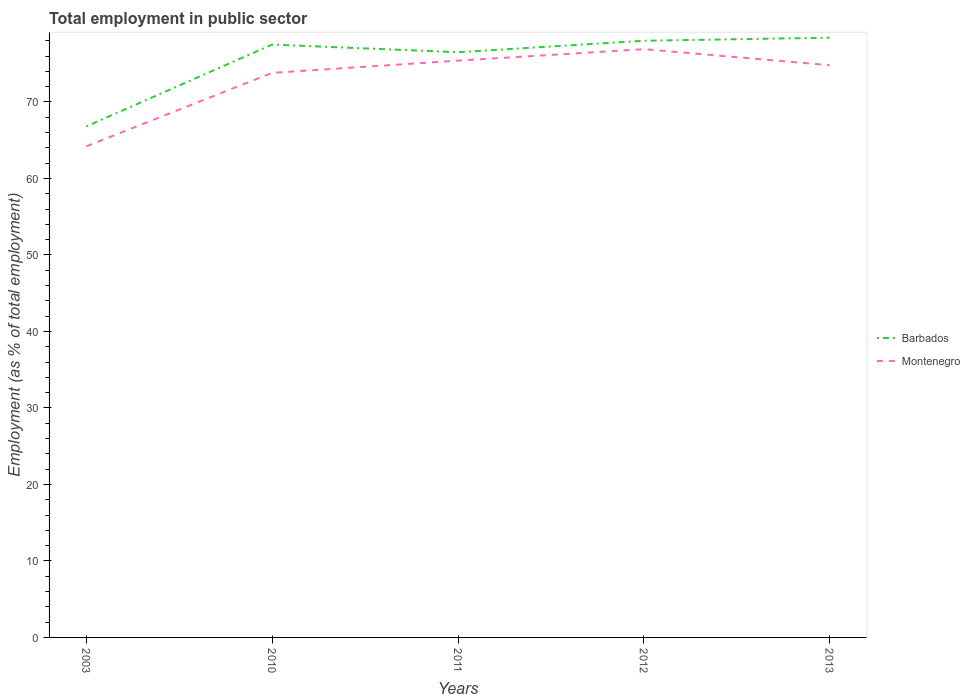How many different coloured lines are there?
Your response must be concise. 2. Does the line corresponding to Barbados intersect with the line corresponding to Montenegro?
Make the answer very short. No. Is the number of lines equal to the number of legend labels?
Ensure brevity in your answer.  Yes. Across all years, what is the maximum employment in public sector in Barbados?
Keep it short and to the point. 66.8. In which year was the employment in public sector in Montenegro maximum?
Make the answer very short. 2003. What is the total employment in public sector in Barbados in the graph?
Ensure brevity in your answer.  -9.7. What is the difference between the highest and the second highest employment in public sector in Montenegro?
Ensure brevity in your answer.  12.7. What is the difference between the highest and the lowest employment in public sector in Barbados?
Your response must be concise. 4. How many years are there in the graph?
Offer a terse response. 5. Does the graph contain grids?
Offer a very short reply. No. Where does the legend appear in the graph?
Provide a succinct answer. Center right. How many legend labels are there?
Offer a very short reply. 2. What is the title of the graph?
Provide a short and direct response. Total employment in public sector. What is the label or title of the X-axis?
Offer a very short reply. Years. What is the label or title of the Y-axis?
Offer a very short reply. Employment (as % of total employment). What is the Employment (as % of total employment) of Barbados in 2003?
Provide a succinct answer. 66.8. What is the Employment (as % of total employment) of Montenegro in 2003?
Provide a succinct answer. 64.2. What is the Employment (as % of total employment) in Barbados in 2010?
Provide a short and direct response. 77.5. What is the Employment (as % of total employment) in Montenegro in 2010?
Offer a very short reply. 73.8. What is the Employment (as % of total employment) in Barbados in 2011?
Offer a very short reply. 76.5. What is the Employment (as % of total employment) of Montenegro in 2011?
Make the answer very short. 75.4. What is the Employment (as % of total employment) of Montenegro in 2012?
Your answer should be compact. 76.9. What is the Employment (as % of total employment) in Barbados in 2013?
Your response must be concise. 78.4. What is the Employment (as % of total employment) in Montenegro in 2013?
Offer a very short reply. 74.8. Across all years, what is the maximum Employment (as % of total employment) of Barbados?
Make the answer very short. 78.4. Across all years, what is the maximum Employment (as % of total employment) of Montenegro?
Offer a very short reply. 76.9. Across all years, what is the minimum Employment (as % of total employment) in Barbados?
Provide a succinct answer. 66.8. Across all years, what is the minimum Employment (as % of total employment) of Montenegro?
Provide a short and direct response. 64.2. What is the total Employment (as % of total employment) of Barbados in the graph?
Your response must be concise. 377.2. What is the total Employment (as % of total employment) of Montenegro in the graph?
Your response must be concise. 365.1. What is the difference between the Employment (as % of total employment) of Barbados in 2003 and that in 2010?
Make the answer very short. -10.7. What is the difference between the Employment (as % of total employment) in Barbados in 2003 and that in 2011?
Provide a succinct answer. -9.7. What is the difference between the Employment (as % of total employment) of Montenegro in 2003 and that in 2011?
Make the answer very short. -11.2. What is the difference between the Employment (as % of total employment) of Barbados in 2010 and that in 2012?
Provide a short and direct response. -0.5. What is the difference between the Employment (as % of total employment) of Montenegro in 2011 and that in 2012?
Keep it short and to the point. -1.5. What is the difference between the Employment (as % of total employment) of Barbados in 2012 and that in 2013?
Give a very brief answer. -0.4. What is the difference between the Employment (as % of total employment) in Barbados in 2003 and the Employment (as % of total employment) in Montenegro in 2010?
Your response must be concise. -7. What is the difference between the Employment (as % of total employment) of Barbados in 2003 and the Employment (as % of total employment) of Montenegro in 2011?
Keep it short and to the point. -8.6. What is the difference between the Employment (as % of total employment) of Barbados in 2003 and the Employment (as % of total employment) of Montenegro in 2012?
Offer a terse response. -10.1. What is the difference between the Employment (as % of total employment) of Barbados in 2003 and the Employment (as % of total employment) of Montenegro in 2013?
Offer a very short reply. -8. What is the difference between the Employment (as % of total employment) in Barbados in 2010 and the Employment (as % of total employment) in Montenegro in 2012?
Your answer should be compact. 0.6. What is the difference between the Employment (as % of total employment) of Barbados in 2010 and the Employment (as % of total employment) of Montenegro in 2013?
Make the answer very short. 2.7. What is the difference between the Employment (as % of total employment) in Barbados in 2011 and the Employment (as % of total employment) in Montenegro in 2012?
Provide a succinct answer. -0.4. What is the average Employment (as % of total employment) of Barbados per year?
Provide a short and direct response. 75.44. What is the average Employment (as % of total employment) of Montenegro per year?
Keep it short and to the point. 73.02. In the year 2003, what is the difference between the Employment (as % of total employment) of Barbados and Employment (as % of total employment) of Montenegro?
Ensure brevity in your answer.  2.6. In the year 2010, what is the difference between the Employment (as % of total employment) in Barbados and Employment (as % of total employment) in Montenegro?
Offer a terse response. 3.7. In the year 2011, what is the difference between the Employment (as % of total employment) of Barbados and Employment (as % of total employment) of Montenegro?
Make the answer very short. 1.1. In the year 2013, what is the difference between the Employment (as % of total employment) of Barbados and Employment (as % of total employment) of Montenegro?
Ensure brevity in your answer.  3.6. What is the ratio of the Employment (as % of total employment) of Barbados in 2003 to that in 2010?
Offer a terse response. 0.86. What is the ratio of the Employment (as % of total employment) in Montenegro in 2003 to that in 2010?
Your answer should be very brief. 0.87. What is the ratio of the Employment (as % of total employment) of Barbados in 2003 to that in 2011?
Offer a very short reply. 0.87. What is the ratio of the Employment (as % of total employment) of Montenegro in 2003 to that in 2011?
Offer a terse response. 0.85. What is the ratio of the Employment (as % of total employment) of Barbados in 2003 to that in 2012?
Provide a succinct answer. 0.86. What is the ratio of the Employment (as % of total employment) in Montenegro in 2003 to that in 2012?
Your answer should be very brief. 0.83. What is the ratio of the Employment (as % of total employment) in Barbados in 2003 to that in 2013?
Ensure brevity in your answer.  0.85. What is the ratio of the Employment (as % of total employment) of Montenegro in 2003 to that in 2013?
Keep it short and to the point. 0.86. What is the ratio of the Employment (as % of total employment) of Barbados in 2010 to that in 2011?
Give a very brief answer. 1.01. What is the ratio of the Employment (as % of total employment) in Montenegro in 2010 to that in 2011?
Your response must be concise. 0.98. What is the ratio of the Employment (as % of total employment) in Montenegro in 2010 to that in 2012?
Your answer should be compact. 0.96. What is the ratio of the Employment (as % of total employment) of Montenegro in 2010 to that in 2013?
Provide a short and direct response. 0.99. What is the ratio of the Employment (as % of total employment) of Barbados in 2011 to that in 2012?
Provide a succinct answer. 0.98. What is the ratio of the Employment (as % of total employment) of Montenegro in 2011 to that in 2012?
Ensure brevity in your answer.  0.98. What is the ratio of the Employment (as % of total employment) in Barbados in 2011 to that in 2013?
Your answer should be very brief. 0.98. What is the ratio of the Employment (as % of total employment) of Barbados in 2012 to that in 2013?
Your response must be concise. 0.99. What is the ratio of the Employment (as % of total employment) in Montenegro in 2012 to that in 2013?
Your answer should be compact. 1.03. What is the difference between the highest and the second highest Employment (as % of total employment) in Barbados?
Your answer should be compact. 0.4. 